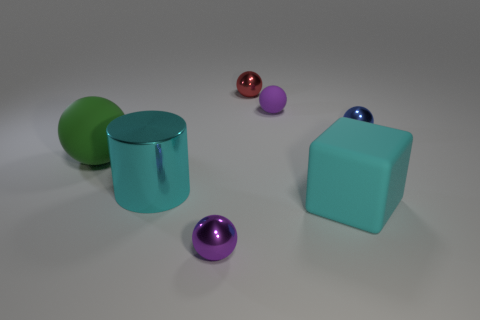The metallic object that is behind the large cyan matte block and to the left of the red ball is what color?
Offer a very short reply. Cyan. How many things are rubber things on the right side of the large sphere or small objects in front of the big cyan shiny cylinder?
Your response must be concise. 3. There is a big matte object left of the small purple object left of the tiny purple ball behind the cyan metallic thing; what is its color?
Your response must be concise. Green. Is there another small matte thing that has the same shape as the tiny purple rubber thing?
Keep it short and to the point. No. How many matte spheres are there?
Keep it short and to the point. 2. The cyan metal thing has what shape?
Make the answer very short. Cylinder. What number of matte blocks have the same size as the cyan matte thing?
Your answer should be compact. 0. Is the tiny blue object the same shape as the big green rubber object?
Provide a succinct answer. Yes. What is the color of the shiny sphere that is behind the small matte object behind the big green object?
Make the answer very short. Red. What size is the metal object that is both to the left of the matte block and behind the green sphere?
Your response must be concise. Small. 